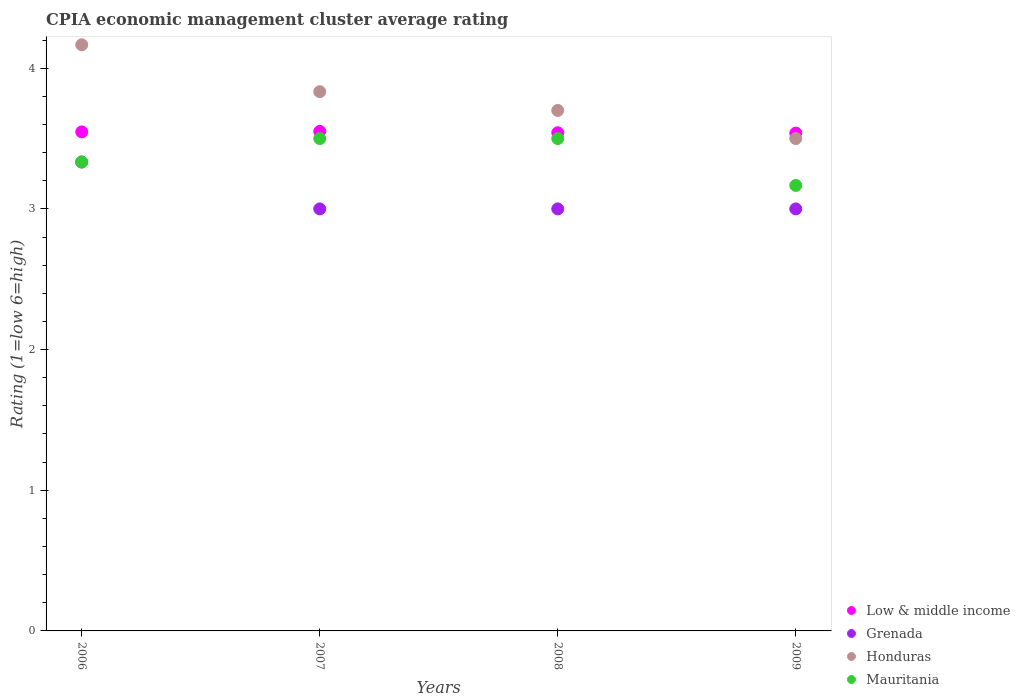How many different coloured dotlines are there?
Provide a succinct answer. 4. What is the CPIA rating in Mauritania in 2009?
Your answer should be compact. 3.17. Across all years, what is the maximum CPIA rating in Low & middle income?
Your answer should be very brief. 3.55. Across all years, what is the minimum CPIA rating in Honduras?
Provide a short and direct response. 3.5. In which year was the CPIA rating in Grenada minimum?
Your response must be concise. 2007. What is the difference between the CPIA rating in Mauritania in 2007 and that in 2008?
Your response must be concise. 0. What is the average CPIA rating in Honduras per year?
Offer a terse response. 3.8. In the year 2009, what is the difference between the CPIA rating in Low & middle income and CPIA rating in Honduras?
Provide a succinct answer. 0.04. What is the ratio of the CPIA rating in Low & middle income in 2008 to that in 2009?
Provide a short and direct response. 1. Is the CPIA rating in Honduras in 2007 less than that in 2009?
Your answer should be compact. No. Is the difference between the CPIA rating in Low & middle income in 2007 and 2008 greater than the difference between the CPIA rating in Honduras in 2007 and 2008?
Give a very brief answer. No. What is the difference between the highest and the second highest CPIA rating in Grenada?
Provide a succinct answer. 0.33. What is the difference between the highest and the lowest CPIA rating in Honduras?
Your answer should be compact. 0.67. Is it the case that in every year, the sum of the CPIA rating in Low & middle income and CPIA rating in Grenada  is greater than the CPIA rating in Honduras?
Provide a succinct answer. Yes. Does the CPIA rating in Honduras monotonically increase over the years?
Offer a very short reply. No. How many years are there in the graph?
Give a very brief answer. 4. What is the difference between two consecutive major ticks on the Y-axis?
Keep it short and to the point. 1. Does the graph contain any zero values?
Offer a terse response. No. Does the graph contain grids?
Your answer should be very brief. No. How are the legend labels stacked?
Offer a very short reply. Vertical. What is the title of the graph?
Offer a very short reply. CPIA economic management cluster average rating. What is the label or title of the X-axis?
Ensure brevity in your answer.  Years. What is the Rating (1=low 6=high) in Low & middle income in 2006?
Ensure brevity in your answer.  3.55. What is the Rating (1=low 6=high) in Grenada in 2006?
Provide a short and direct response. 3.33. What is the Rating (1=low 6=high) of Honduras in 2006?
Keep it short and to the point. 4.17. What is the Rating (1=low 6=high) of Mauritania in 2006?
Offer a very short reply. 3.33. What is the Rating (1=low 6=high) of Low & middle income in 2007?
Your response must be concise. 3.55. What is the Rating (1=low 6=high) of Honduras in 2007?
Your answer should be very brief. 3.83. What is the Rating (1=low 6=high) of Mauritania in 2007?
Your answer should be compact. 3.5. What is the Rating (1=low 6=high) in Low & middle income in 2008?
Make the answer very short. 3.54. What is the Rating (1=low 6=high) in Honduras in 2008?
Offer a very short reply. 3.7. What is the Rating (1=low 6=high) in Low & middle income in 2009?
Your answer should be very brief. 3.54. What is the Rating (1=low 6=high) of Grenada in 2009?
Make the answer very short. 3. What is the Rating (1=low 6=high) of Honduras in 2009?
Offer a terse response. 3.5. What is the Rating (1=low 6=high) in Mauritania in 2009?
Make the answer very short. 3.17. Across all years, what is the maximum Rating (1=low 6=high) in Low & middle income?
Your answer should be very brief. 3.55. Across all years, what is the maximum Rating (1=low 6=high) in Grenada?
Your answer should be compact. 3.33. Across all years, what is the maximum Rating (1=low 6=high) in Honduras?
Ensure brevity in your answer.  4.17. Across all years, what is the minimum Rating (1=low 6=high) of Low & middle income?
Provide a succinct answer. 3.54. Across all years, what is the minimum Rating (1=low 6=high) in Grenada?
Make the answer very short. 3. Across all years, what is the minimum Rating (1=low 6=high) in Honduras?
Offer a very short reply. 3.5. Across all years, what is the minimum Rating (1=low 6=high) in Mauritania?
Provide a succinct answer. 3.17. What is the total Rating (1=low 6=high) of Low & middle income in the graph?
Give a very brief answer. 14.18. What is the total Rating (1=low 6=high) in Grenada in the graph?
Provide a succinct answer. 12.33. What is the total Rating (1=low 6=high) in Mauritania in the graph?
Provide a short and direct response. 13.5. What is the difference between the Rating (1=low 6=high) of Low & middle income in 2006 and that in 2007?
Your response must be concise. -0. What is the difference between the Rating (1=low 6=high) in Grenada in 2006 and that in 2007?
Keep it short and to the point. 0.33. What is the difference between the Rating (1=low 6=high) of Mauritania in 2006 and that in 2007?
Provide a succinct answer. -0.17. What is the difference between the Rating (1=low 6=high) of Low & middle income in 2006 and that in 2008?
Your response must be concise. 0.01. What is the difference between the Rating (1=low 6=high) in Honduras in 2006 and that in 2008?
Make the answer very short. 0.47. What is the difference between the Rating (1=low 6=high) of Low & middle income in 2006 and that in 2009?
Offer a terse response. 0.01. What is the difference between the Rating (1=low 6=high) of Grenada in 2006 and that in 2009?
Offer a terse response. 0.33. What is the difference between the Rating (1=low 6=high) of Honduras in 2006 and that in 2009?
Make the answer very short. 0.67. What is the difference between the Rating (1=low 6=high) of Mauritania in 2006 and that in 2009?
Make the answer very short. 0.17. What is the difference between the Rating (1=low 6=high) in Low & middle income in 2007 and that in 2008?
Your response must be concise. 0.01. What is the difference between the Rating (1=low 6=high) in Grenada in 2007 and that in 2008?
Your response must be concise. 0. What is the difference between the Rating (1=low 6=high) of Honduras in 2007 and that in 2008?
Give a very brief answer. 0.13. What is the difference between the Rating (1=low 6=high) in Low & middle income in 2007 and that in 2009?
Provide a short and direct response. 0.01. What is the difference between the Rating (1=low 6=high) in Grenada in 2007 and that in 2009?
Provide a succinct answer. 0. What is the difference between the Rating (1=low 6=high) of Low & middle income in 2008 and that in 2009?
Your response must be concise. 0. What is the difference between the Rating (1=low 6=high) of Mauritania in 2008 and that in 2009?
Offer a terse response. 0.33. What is the difference between the Rating (1=low 6=high) of Low & middle income in 2006 and the Rating (1=low 6=high) of Grenada in 2007?
Your response must be concise. 0.55. What is the difference between the Rating (1=low 6=high) in Low & middle income in 2006 and the Rating (1=low 6=high) in Honduras in 2007?
Provide a short and direct response. -0.29. What is the difference between the Rating (1=low 6=high) of Low & middle income in 2006 and the Rating (1=low 6=high) of Mauritania in 2007?
Provide a short and direct response. 0.05. What is the difference between the Rating (1=low 6=high) in Grenada in 2006 and the Rating (1=low 6=high) in Mauritania in 2007?
Offer a terse response. -0.17. What is the difference between the Rating (1=low 6=high) in Low & middle income in 2006 and the Rating (1=low 6=high) in Grenada in 2008?
Make the answer very short. 0.55. What is the difference between the Rating (1=low 6=high) in Low & middle income in 2006 and the Rating (1=low 6=high) in Honduras in 2008?
Make the answer very short. -0.15. What is the difference between the Rating (1=low 6=high) of Low & middle income in 2006 and the Rating (1=low 6=high) of Mauritania in 2008?
Provide a succinct answer. 0.05. What is the difference between the Rating (1=low 6=high) in Grenada in 2006 and the Rating (1=low 6=high) in Honduras in 2008?
Ensure brevity in your answer.  -0.37. What is the difference between the Rating (1=low 6=high) of Grenada in 2006 and the Rating (1=low 6=high) of Mauritania in 2008?
Offer a very short reply. -0.17. What is the difference between the Rating (1=low 6=high) of Honduras in 2006 and the Rating (1=low 6=high) of Mauritania in 2008?
Provide a succinct answer. 0.67. What is the difference between the Rating (1=low 6=high) in Low & middle income in 2006 and the Rating (1=low 6=high) in Grenada in 2009?
Ensure brevity in your answer.  0.55. What is the difference between the Rating (1=low 6=high) in Low & middle income in 2006 and the Rating (1=low 6=high) in Honduras in 2009?
Give a very brief answer. 0.05. What is the difference between the Rating (1=low 6=high) of Low & middle income in 2006 and the Rating (1=low 6=high) of Mauritania in 2009?
Keep it short and to the point. 0.38. What is the difference between the Rating (1=low 6=high) in Grenada in 2006 and the Rating (1=low 6=high) in Honduras in 2009?
Your answer should be compact. -0.17. What is the difference between the Rating (1=low 6=high) of Grenada in 2006 and the Rating (1=low 6=high) of Mauritania in 2009?
Provide a short and direct response. 0.17. What is the difference between the Rating (1=low 6=high) in Low & middle income in 2007 and the Rating (1=low 6=high) in Grenada in 2008?
Make the answer very short. 0.55. What is the difference between the Rating (1=low 6=high) in Low & middle income in 2007 and the Rating (1=low 6=high) in Honduras in 2008?
Provide a short and direct response. -0.15. What is the difference between the Rating (1=low 6=high) in Low & middle income in 2007 and the Rating (1=low 6=high) in Mauritania in 2008?
Provide a succinct answer. 0.05. What is the difference between the Rating (1=low 6=high) in Low & middle income in 2007 and the Rating (1=low 6=high) in Grenada in 2009?
Offer a very short reply. 0.55. What is the difference between the Rating (1=low 6=high) in Low & middle income in 2007 and the Rating (1=low 6=high) in Honduras in 2009?
Offer a terse response. 0.05. What is the difference between the Rating (1=low 6=high) of Low & middle income in 2007 and the Rating (1=low 6=high) of Mauritania in 2009?
Your response must be concise. 0.38. What is the difference between the Rating (1=low 6=high) of Grenada in 2007 and the Rating (1=low 6=high) of Mauritania in 2009?
Your answer should be very brief. -0.17. What is the difference between the Rating (1=low 6=high) in Low & middle income in 2008 and the Rating (1=low 6=high) in Grenada in 2009?
Provide a succinct answer. 0.54. What is the difference between the Rating (1=low 6=high) of Low & middle income in 2008 and the Rating (1=low 6=high) of Honduras in 2009?
Give a very brief answer. 0.04. What is the difference between the Rating (1=low 6=high) of Low & middle income in 2008 and the Rating (1=low 6=high) of Mauritania in 2009?
Provide a short and direct response. 0.37. What is the difference between the Rating (1=low 6=high) of Grenada in 2008 and the Rating (1=low 6=high) of Honduras in 2009?
Make the answer very short. -0.5. What is the difference between the Rating (1=low 6=high) in Honduras in 2008 and the Rating (1=low 6=high) in Mauritania in 2009?
Your response must be concise. 0.53. What is the average Rating (1=low 6=high) in Low & middle income per year?
Offer a terse response. 3.54. What is the average Rating (1=low 6=high) in Grenada per year?
Offer a very short reply. 3.08. What is the average Rating (1=low 6=high) of Mauritania per year?
Your response must be concise. 3.38. In the year 2006, what is the difference between the Rating (1=low 6=high) of Low & middle income and Rating (1=low 6=high) of Grenada?
Ensure brevity in your answer.  0.21. In the year 2006, what is the difference between the Rating (1=low 6=high) in Low & middle income and Rating (1=low 6=high) in Honduras?
Keep it short and to the point. -0.62. In the year 2006, what is the difference between the Rating (1=low 6=high) of Low & middle income and Rating (1=low 6=high) of Mauritania?
Your answer should be compact. 0.21. In the year 2006, what is the difference between the Rating (1=low 6=high) of Grenada and Rating (1=low 6=high) of Honduras?
Give a very brief answer. -0.83. In the year 2006, what is the difference between the Rating (1=low 6=high) in Grenada and Rating (1=low 6=high) in Mauritania?
Your answer should be very brief. 0. In the year 2006, what is the difference between the Rating (1=low 6=high) in Honduras and Rating (1=low 6=high) in Mauritania?
Your answer should be very brief. 0.83. In the year 2007, what is the difference between the Rating (1=low 6=high) in Low & middle income and Rating (1=low 6=high) in Grenada?
Your answer should be compact. 0.55. In the year 2007, what is the difference between the Rating (1=low 6=high) of Low & middle income and Rating (1=low 6=high) of Honduras?
Ensure brevity in your answer.  -0.28. In the year 2007, what is the difference between the Rating (1=low 6=high) in Low & middle income and Rating (1=low 6=high) in Mauritania?
Your answer should be compact. 0.05. In the year 2007, what is the difference between the Rating (1=low 6=high) in Grenada and Rating (1=low 6=high) in Honduras?
Provide a succinct answer. -0.83. In the year 2008, what is the difference between the Rating (1=low 6=high) of Low & middle income and Rating (1=low 6=high) of Grenada?
Make the answer very short. 0.54. In the year 2008, what is the difference between the Rating (1=low 6=high) of Low & middle income and Rating (1=low 6=high) of Honduras?
Provide a succinct answer. -0.16. In the year 2008, what is the difference between the Rating (1=low 6=high) in Low & middle income and Rating (1=low 6=high) in Mauritania?
Keep it short and to the point. 0.04. In the year 2009, what is the difference between the Rating (1=low 6=high) in Low & middle income and Rating (1=low 6=high) in Grenada?
Your answer should be compact. 0.54. In the year 2009, what is the difference between the Rating (1=low 6=high) in Low & middle income and Rating (1=low 6=high) in Honduras?
Give a very brief answer. 0.04. In the year 2009, what is the difference between the Rating (1=low 6=high) in Low & middle income and Rating (1=low 6=high) in Mauritania?
Make the answer very short. 0.37. In the year 2009, what is the difference between the Rating (1=low 6=high) in Grenada and Rating (1=low 6=high) in Honduras?
Offer a terse response. -0.5. What is the ratio of the Rating (1=low 6=high) in Honduras in 2006 to that in 2007?
Your answer should be very brief. 1.09. What is the ratio of the Rating (1=low 6=high) of Mauritania in 2006 to that in 2007?
Offer a terse response. 0.95. What is the ratio of the Rating (1=low 6=high) in Low & middle income in 2006 to that in 2008?
Make the answer very short. 1. What is the ratio of the Rating (1=low 6=high) in Grenada in 2006 to that in 2008?
Make the answer very short. 1.11. What is the ratio of the Rating (1=low 6=high) in Honduras in 2006 to that in 2008?
Offer a terse response. 1.13. What is the ratio of the Rating (1=low 6=high) in Low & middle income in 2006 to that in 2009?
Your response must be concise. 1. What is the ratio of the Rating (1=low 6=high) of Honduras in 2006 to that in 2009?
Provide a succinct answer. 1.19. What is the ratio of the Rating (1=low 6=high) in Mauritania in 2006 to that in 2009?
Offer a very short reply. 1.05. What is the ratio of the Rating (1=low 6=high) in Honduras in 2007 to that in 2008?
Ensure brevity in your answer.  1.04. What is the ratio of the Rating (1=low 6=high) of Grenada in 2007 to that in 2009?
Offer a terse response. 1. What is the ratio of the Rating (1=low 6=high) of Honduras in 2007 to that in 2009?
Offer a terse response. 1.1. What is the ratio of the Rating (1=low 6=high) in Mauritania in 2007 to that in 2009?
Provide a short and direct response. 1.11. What is the ratio of the Rating (1=low 6=high) in Grenada in 2008 to that in 2009?
Offer a terse response. 1. What is the ratio of the Rating (1=low 6=high) of Honduras in 2008 to that in 2009?
Offer a terse response. 1.06. What is the ratio of the Rating (1=low 6=high) of Mauritania in 2008 to that in 2009?
Provide a succinct answer. 1.11. What is the difference between the highest and the second highest Rating (1=low 6=high) in Low & middle income?
Your response must be concise. 0. What is the difference between the highest and the second highest Rating (1=low 6=high) of Honduras?
Keep it short and to the point. 0.33. What is the difference between the highest and the lowest Rating (1=low 6=high) of Low & middle income?
Keep it short and to the point. 0.01. What is the difference between the highest and the lowest Rating (1=low 6=high) of Grenada?
Make the answer very short. 0.33. 